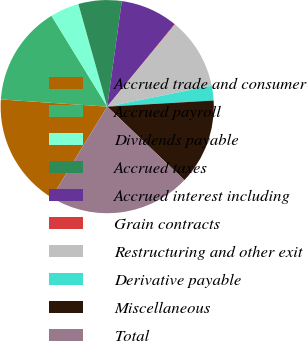<chart> <loc_0><loc_0><loc_500><loc_500><pie_chart><fcel>Accrued trade and consumer<fcel>Accrued payroll<fcel>Dividends payable<fcel>Accrued taxes<fcel>Accrued interest including<fcel>Grain contracts<fcel>Restructuring and other exit<fcel>Derivative payable<fcel>Miscellaneous<fcel>Total<nl><fcel>17.33%<fcel>15.17%<fcel>4.4%<fcel>6.55%<fcel>8.71%<fcel>0.09%<fcel>10.86%<fcel>2.24%<fcel>13.02%<fcel>21.64%<nl></chart> 